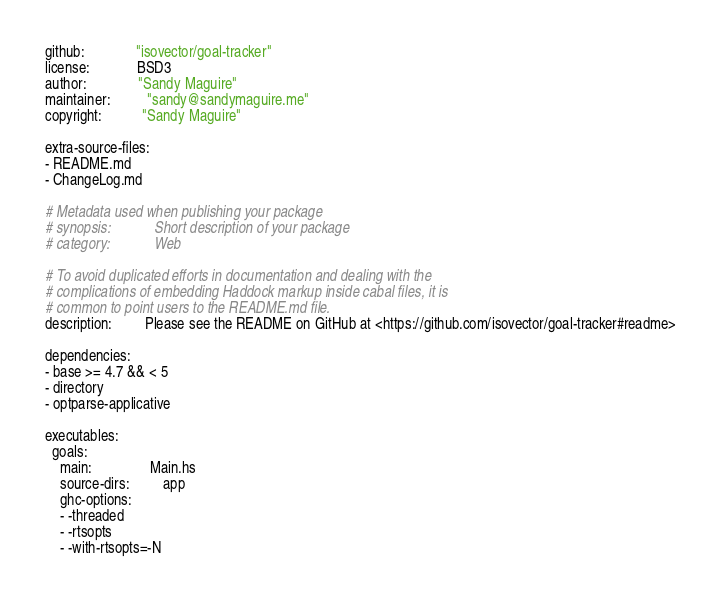<code> <loc_0><loc_0><loc_500><loc_500><_YAML_>github:              "isovector/goal-tracker"
license:             BSD3
author:              "Sandy Maguire"
maintainer:          "sandy@sandymaguire.me"
copyright:           "Sandy Maguire"

extra-source-files:
- README.md
- ChangeLog.md

# Metadata used when publishing your package
# synopsis:            Short description of your package
# category:            Web

# To avoid duplicated efforts in documentation and dealing with the
# complications of embedding Haddock markup inside cabal files, it is
# common to point users to the README.md file.
description:         Please see the README on GitHub at <https://github.com/isovector/goal-tracker#readme>

dependencies:
- base >= 4.7 && < 5
- directory
- optparse-applicative

executables:
  goals:
    main:                Main.hs
    source-dirs:         app
    ghc-options:
    - -threaded
    - -rtsopts
    - -with-rtsopts=-N
</code> 